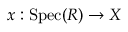<formula> <loc_0><loc_0><loc_500><loc_500>x \colon { S p e c } ( R ) \to X</formula> 